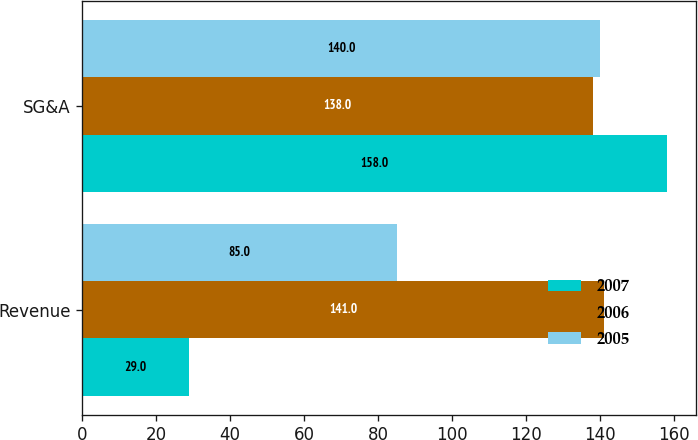<chart> <loc_0><loc_0><loc_500><loc_500><stacked_bar_chart><ecel><fcel>Revenue<fcel>SG&A<nl><fcel>2007<fcel>29<fcel>158<nl><fcel>2006<fcel>141<fcel>138<nl><fcel>2005<fcel>85<fcel>140<nl></chart> 